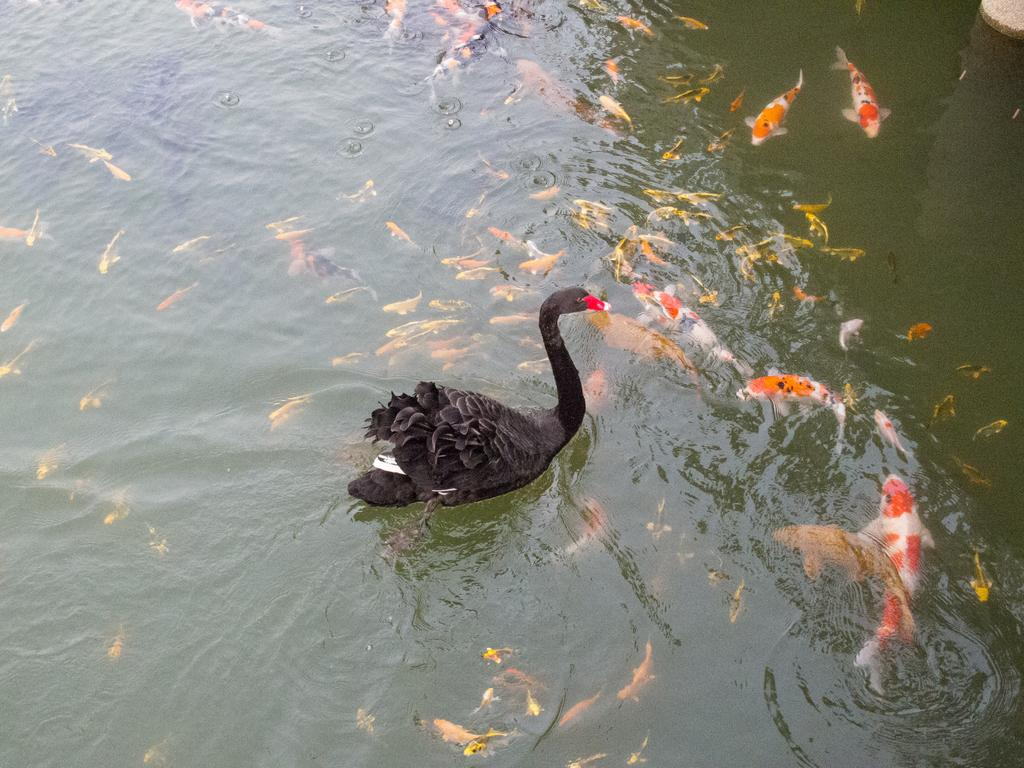What animal is the main subject of the picture? There is a swan in the picture. What can be seen in the background of the picture? There are fish in the water in the background of the picture. How many clocks are visible in the picture? There are no clocks visible in the picture; it features a swan and fish in the water. What type of dirt can be seen on the swan's feathers in the picture? There is no dirt visible on the swan's feathers in the picture; the swan appears to be clean. 